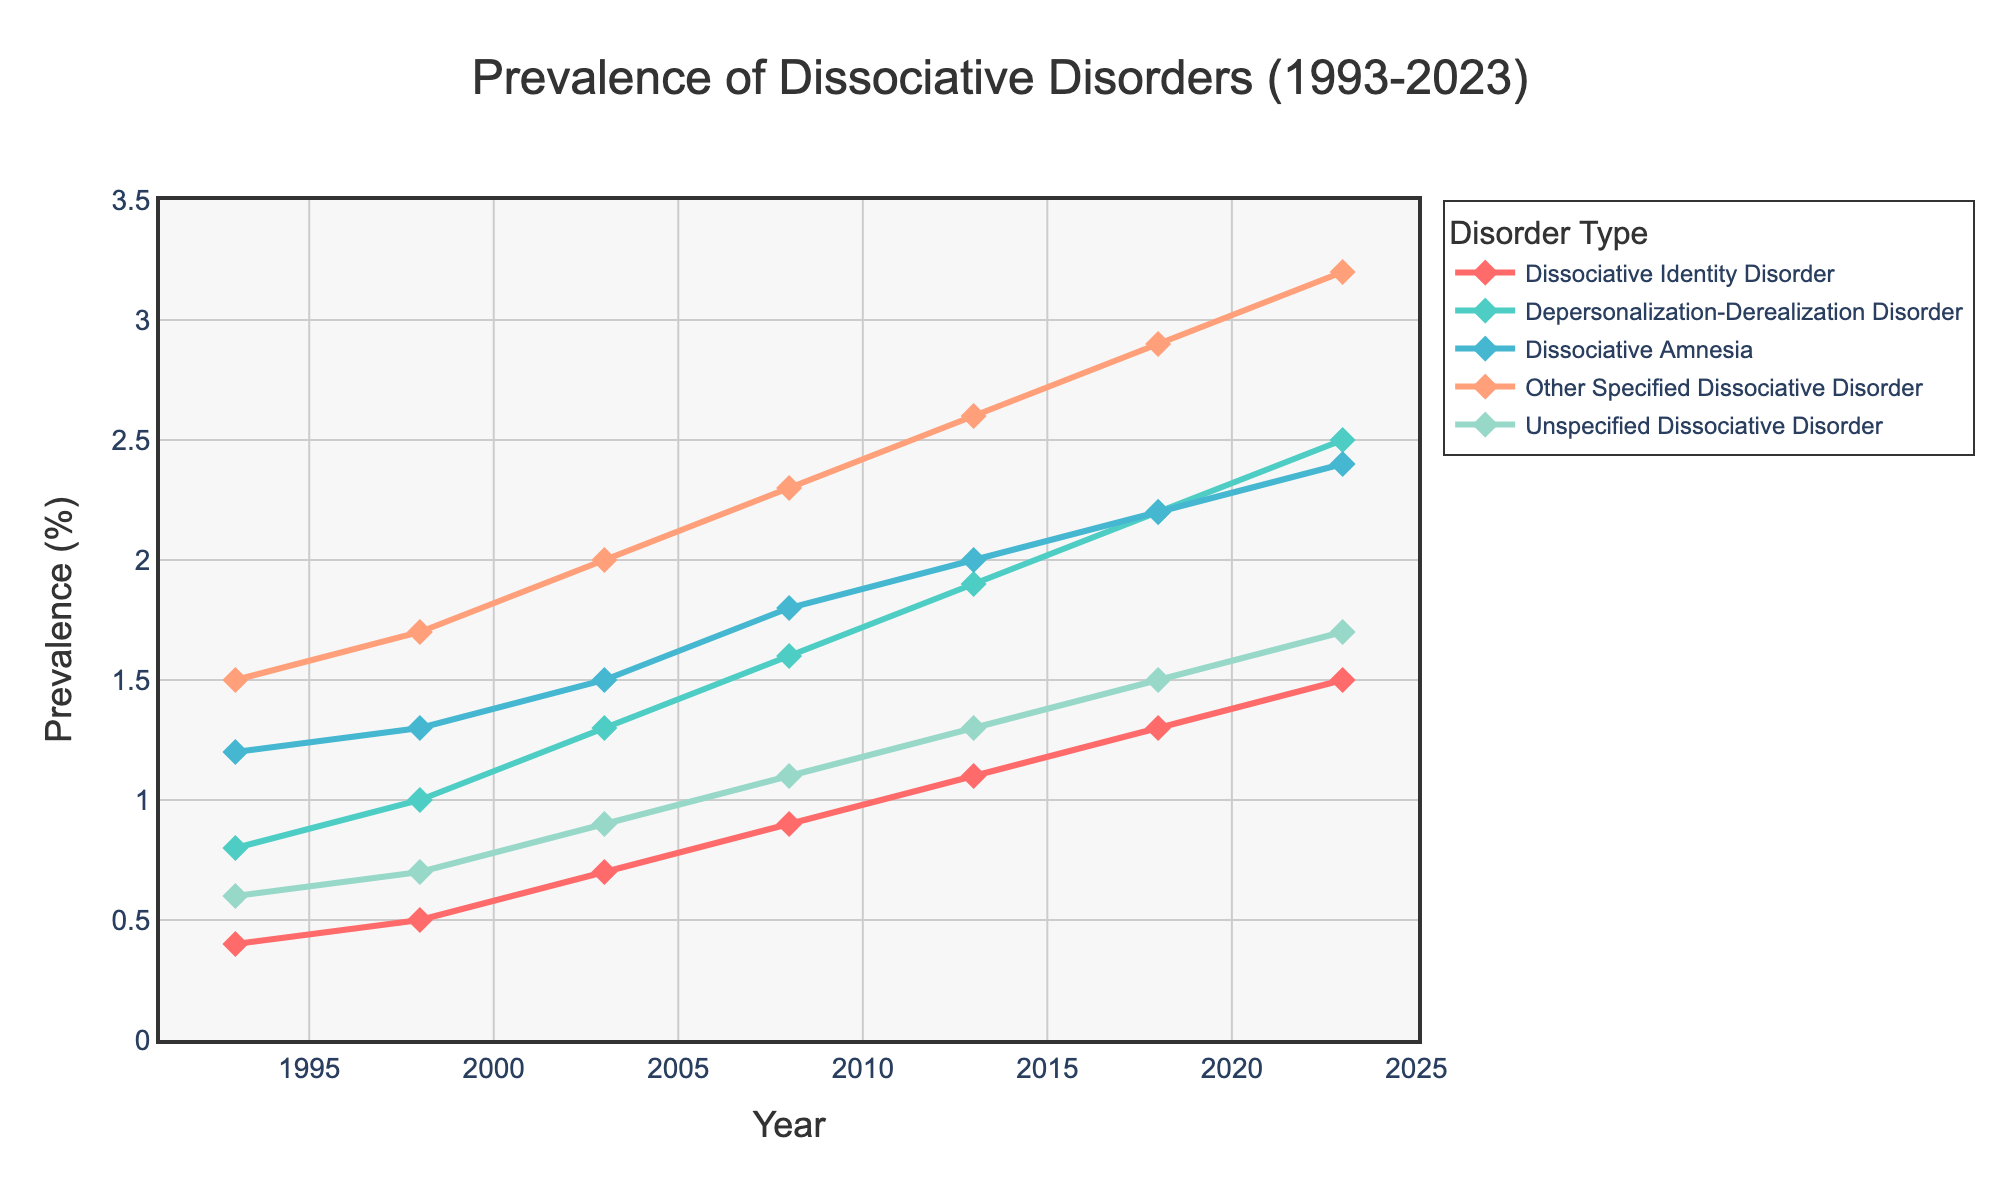What is the prevalence of Dissociative Amnesia in 2003? Locate the data point for Dissociative Amnesia in 2003 on the line chart. It is at 1.5%
Answer: 1.5% Which disorder had the highest prevalence in 2023? Compare the end points of all lines at the year 2023. The line for Other Specified Dissociative Disorder is the highest, at 3.2%
Answer: Other Specified Dissociative Disorder How did the prevalence of Depersonalization-Derealization Disorder change from 1993 to 2023? Look at the start and end points of the Depersonalization-Derealization Disorder line. It starts at 0.8% in 1993 and ends at 2.5% in 2023. The increase is 2.5% - 0.8% = 1.7%
Answer: Increased by 1.7% Which two disorders had the closest prevalence in 1998? Compare the values for all disorders in 1998. Depersonalization-Derealization Disorder and Dissociative Amnesia are closest with values of 1.0% and 1.3%, respectively, giving a difference of 0.3%
Answer: Depersonalization-Derealization Disorder and Dissociative Amnesia What is the average prevalence of Unspecified Dissociative Disorder over the 30-year period? Sum the prevalence values for Unspecified Dissociative Disorder from 1993 to 2023 (0.6 + 0.7 + 0.9 + 1.1 + 1.3 + 1.5 + 1.7) = 7.8, then divide by the number of years (7): 7.8/7 = 1.114
Answer: 1.114% Which disorder showed the greatest increase in prevalence between 2008 and 2023? Calculate the increase for each disorder between 2008 and 2023 by subtracting the 2008 value from the 2023 value. Determine which is largest: DID (1.5-0.9=0.6), DP-DRD (2.5-1.6=0.9), DA (2.4-1.8=0.6), OSDD (3.2-2.3=0.9), UDD (1.7-1.1=0.6). DP-DRD and OSDD both increased by 0.9%
Answer: Depersonalization-Derealization Disorder and Other Specified Dissociative Disorder What was the combined prevalence of all disorders in 2013? Sum the values for each disorder in 2013: 1.1 + 1.9 + 2.0 + 2.6 + 1.3 = 8.9
Answer: 8.9% Which color represents Dissociative Identity Disorder on the chart? Identify the color of the line corresponding to Dissociative Identity Disorder. It is the red line.
Answer: Red By how much did the prevalence of Other Specified Dissociative Disorder increase from 1993 to 2008? Find the difference in prevalence from 1993 (1.5%) to 2008 (2.3%): 2.3% - 1.5% = 0.8%
Answer: 0.8% Between which consecutive years did Dissociative Identity Disorder show the greatest increase in prevalence? Calculate the increase between each pair of consecutive years and identify the largest: (1993-1998: 0.5-0.4=0.1), (1998-2003: 0.7-0.5=0.2), (2003-2008: 0.9-0.7=0.2), (2008-2013: 1.1-0.9=0.2), (2013-2018: 1.3-1.1=0.2), (2018-2023: 1.5-1.3=0.2). The largest increase is 0.2% and occurs in several periods
Answer: 1998-2003, 2003-2008, 2008-2013, 2013-2018, 2018-2023 